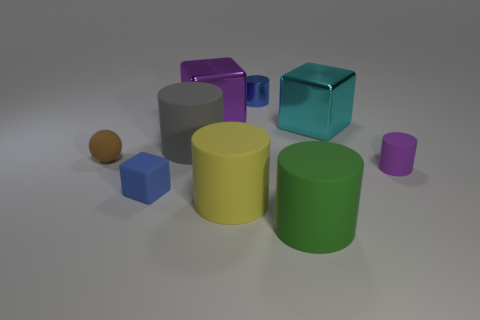Subtract all small purple matte cylinders. How many cylinders are left? 4 Subtract all red cubes. Subtract all brown balls. How many cubes are left? 3 Add 1 gray matte cylinders. How many objects exist? 10 Subtract all cylinders. How many objects are left? 4 Add 5 purple metallic things. How many purple metallic things exist? 6 Subtract 0 cyan spheres. How many objects are left? 9 Subtract all yellow rubber cylinders. Subtract all large gray objects. How many objects are left? 7 Add 8 tiny rubber spheres. How many tiny rubber spheres are left? 9 